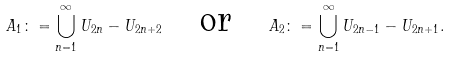<formula> <loc_0><loc_0><loc_500><loc_500>A _ { 1 } \colon = \bigcup _ { n = 1 } ^ { \infty } U _ { 2 n } - U _ { 2 n + 2 } \quad \text {or} \quad A _ { 2 } \colon = \bigcup _ { n = 1 } ^ { \infty } U _ { 2 n - 1 } - U _ { 2 n + 1 } .</formula> 